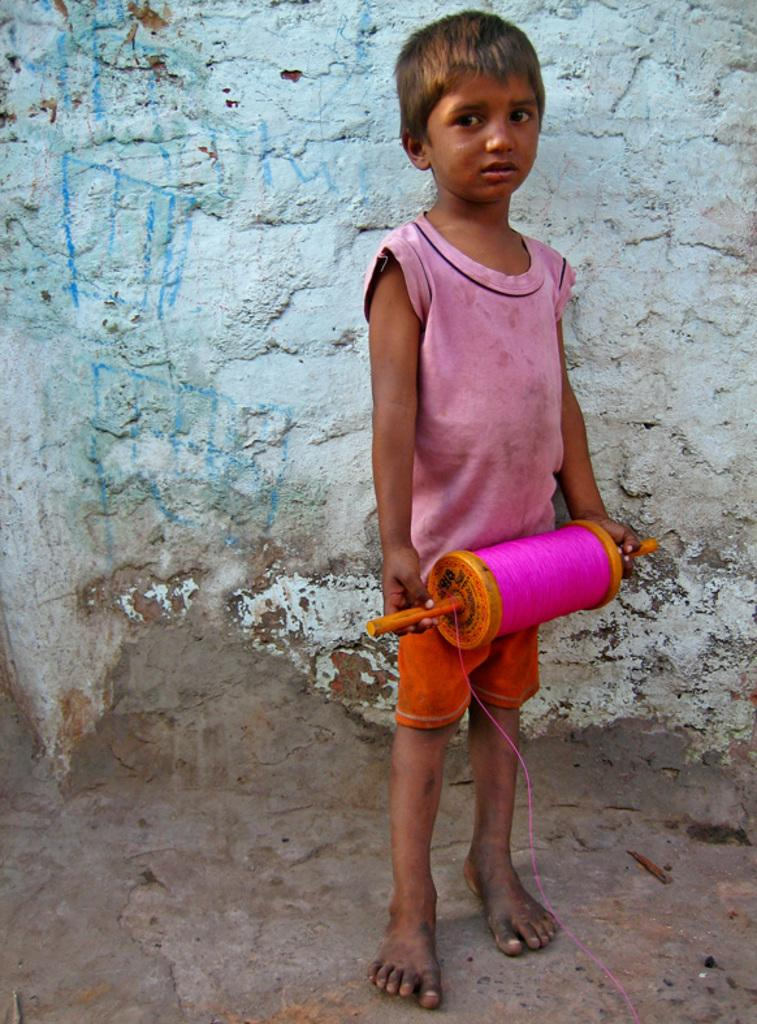What is the main subject of the image? The main subject of the image is a kid standing on the floor. What is the kid holding in their hands? The kid is holding an object in their hands. What can be seen in the background of the image? There is a wall in the background of the image. Can you see any trucks or a lake in the image? No, there are no trucks or a lake present in the image. What type of wrench is the kid using in the image? There is no wrench visible in the image; the kid is holding an unspecified object. 